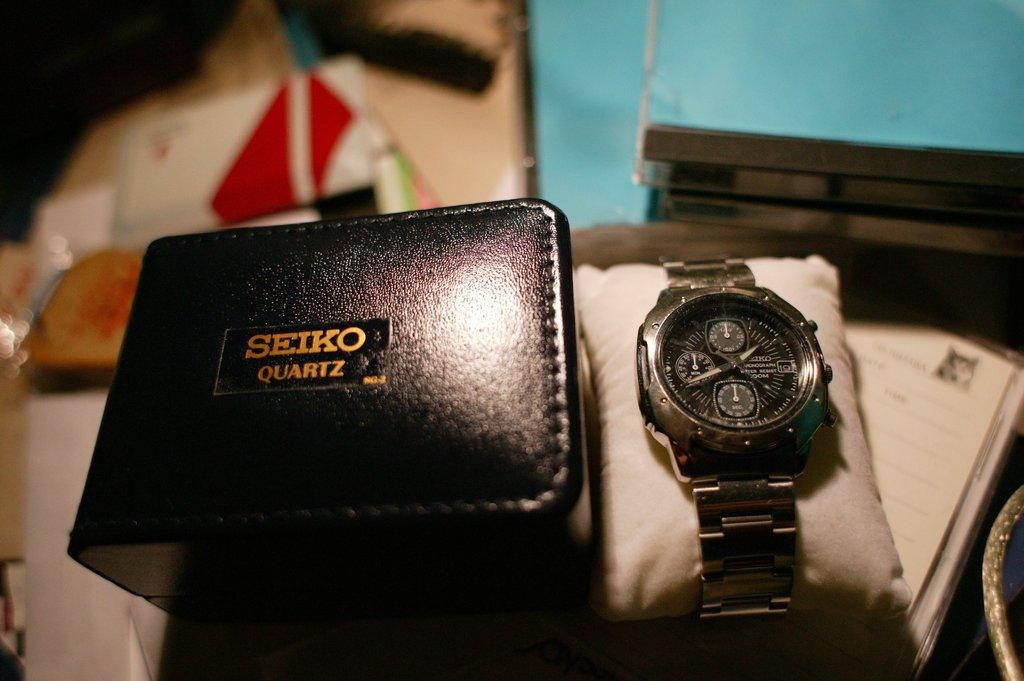Provide a one-sentence caption for the provided image. A silver watch is to the right of a Seiko Quartz black box. 